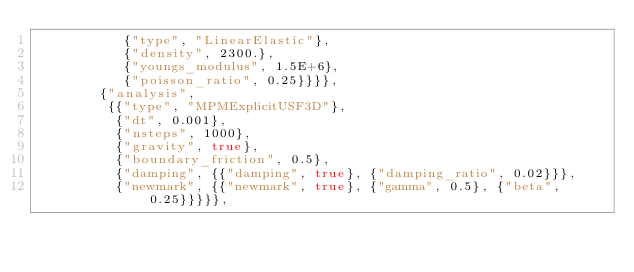<code> <loc_0><loc_0><loc_500><loc_500><_C++_>           {"type", "LinearElastic"},
           {"density", 2300.},
           {"youngs_modulus", 1.5E+6},
           {"poisson_ratio", 0.25}}}},
        {"analysis",
         {{"type", "MPMExplicitUSF3D"},
          {"dt", 0.001},
          {"nsteps", 1000},
          {"gravity", true},
          {"boundary_friction", 0.5},
          {"damping", {{"damping", true}, {"damping_ratio", 0.02}}},
          {"newmark", {{"newmark", true}, {"gamma", 0.5}, {"beta", 0.25}}}}},</code> 